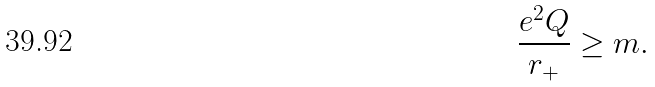<formula> <loc_0><loc_0><loc_500><loc_500>\frac { e ^ { 2 } Q } { r _ { + } } \geq m .</formula> 